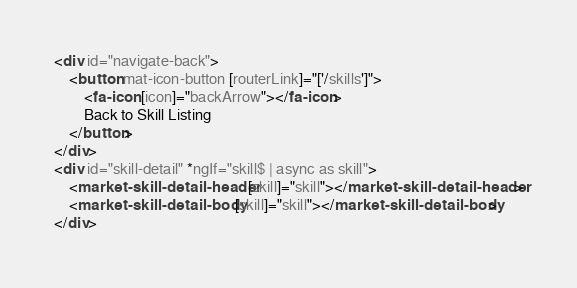Convert code to text. <code><loc_0><loc_0><loc_500><loc_500><_HTML_><div id="navigate-back">
    <button mat-icon-button [routerLink]="['/skills']">
        <fa-icon [icon]="backArrow"></fa-icon>
        Back to Skill Listing
    </button>
</div>
<div id="skill-detail" *ngIf="skill$ | async as skill">
    <market-skill-detail-header [skill]="skill"></market-skill-detail-header>
    <market-skill-detail-body [skill]="skill"></market-skill-detail-body>
</div>
</code> 